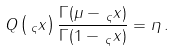Convert formula to latex. <formula><loc_0><loc_0><loc_500><loc_500>Q \left ( \, _ { \varsigma } x \right ) \frac { \Gamma ( \mu - \, _ { \varsigma } x ) } { \Gamma ( 1 - \, _ { \varsigma } x ) } = \eta \, .</formula> 